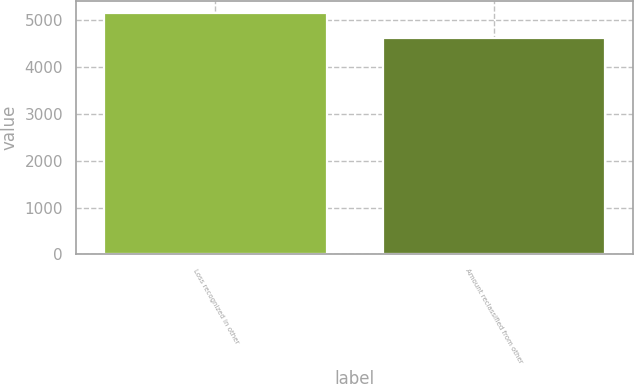Convert chart to OTSL. <chart><loc_0><loc_0><loc_500><loc_500><bar_chart><fcel>Loss recognized in other<fcel>Amount reclassified from other<nl><fcel>5152<fcel>4614<nl></chart> 